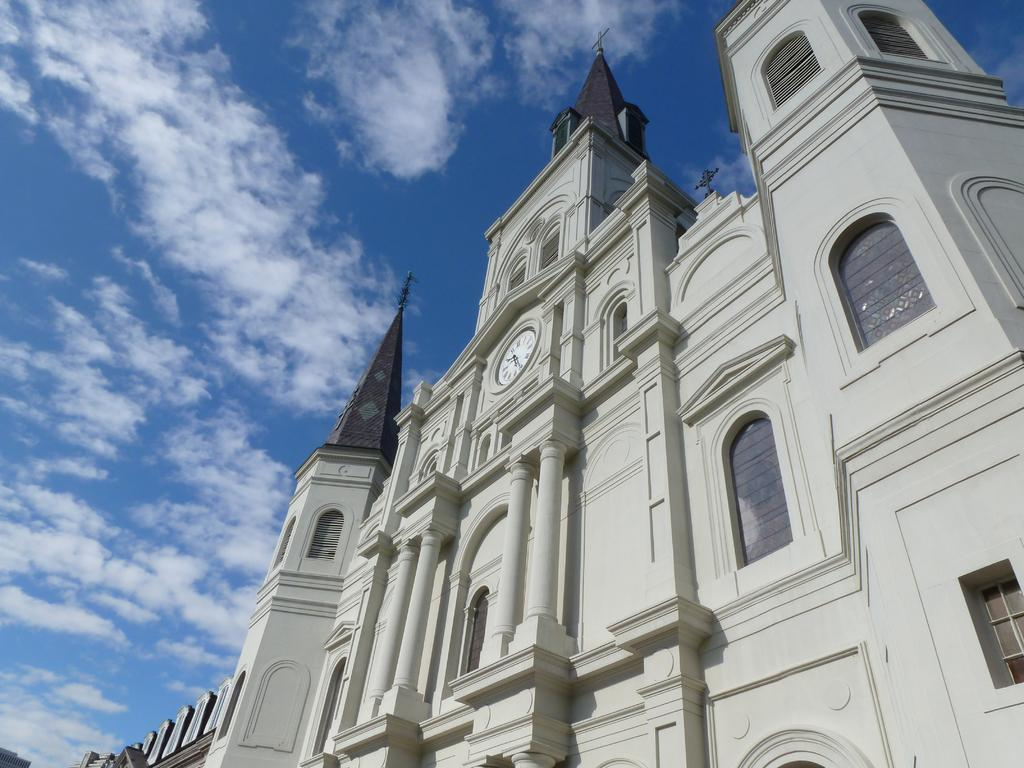What type of structure is in the image? There is a tall building in the image. From where was the image taken? The image is taken from the bottom of the building. What color is the sky in the image? The sky is blue in the image. What type of yoke is used for the treatment in the image? There is no yoke or treatment present in the image; it features a tall building with a blue sky. 